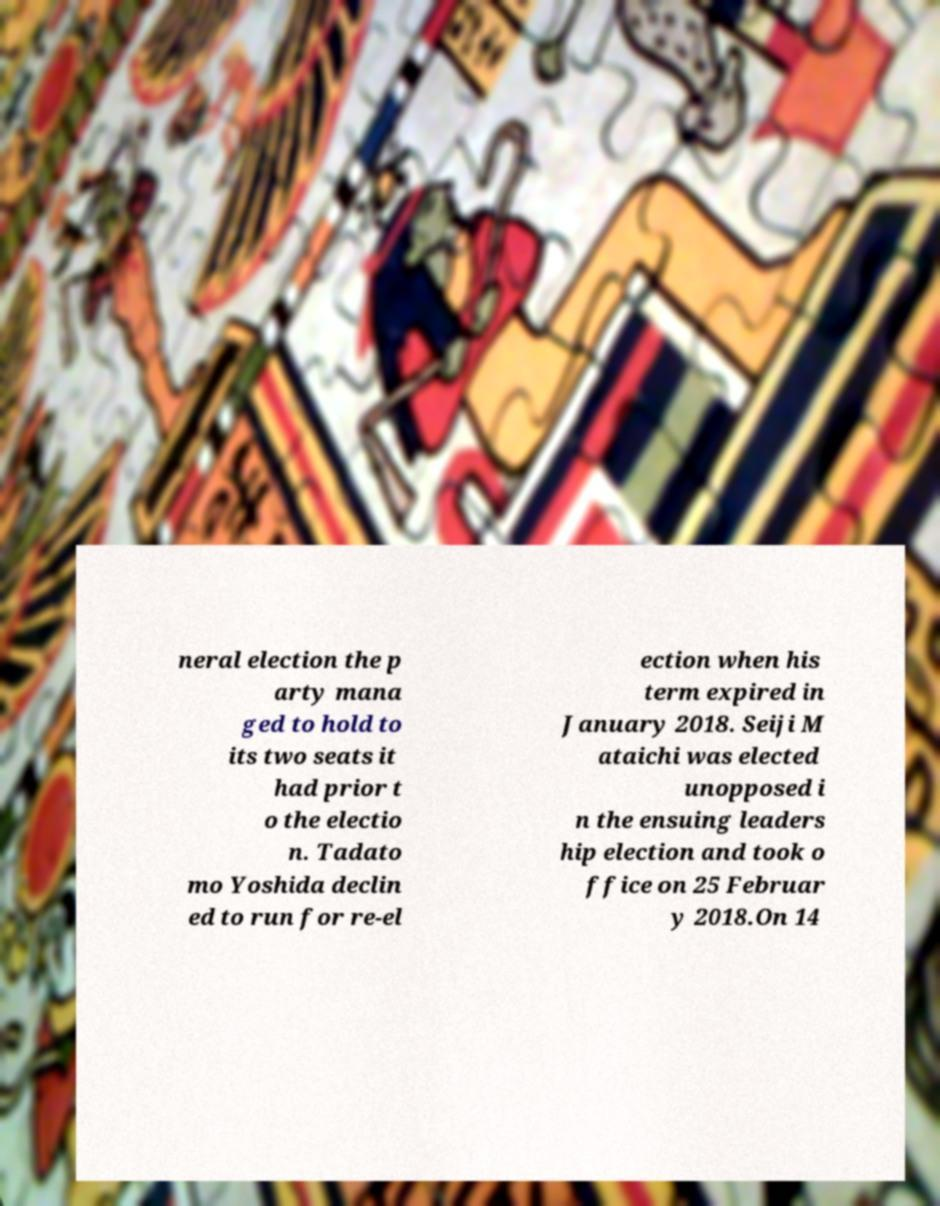I need the written content from this picture converted into text. Can you do that? neral election the p arty mana ged to hold to its two seats it had prior t o the electio n. Tadato mo Yoshida declin ed to run for re-el ection when his term expired in January 2018. Seiji M ataichi was elected unopposed i n the ensuing leaders hip election and took o ffice on 25 Februar y 2018.On 14 